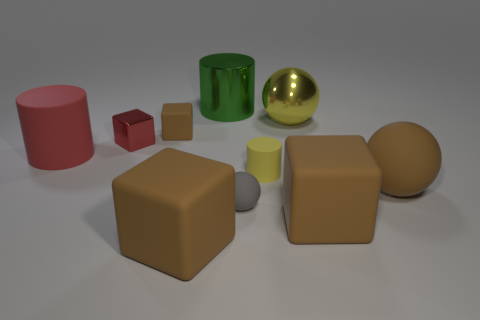How many brown cubes must be subtracted to get 1 brown cubes? 2 Subtract all purple spheres. How many brown cubes are left? 3 Subtract all cylinders. How many objects are left? 7 Add 3 matte cylinders. How many matte cylinders are left? 5 Add 4 big metallic cylinders. How many big metallic cylinders exist? 5 Subtract 0 yellow blocks. How many objects are left? 10 Subtract all tiny gray rubber objects. Subtract all tiny balls. How many objects are left? 8 